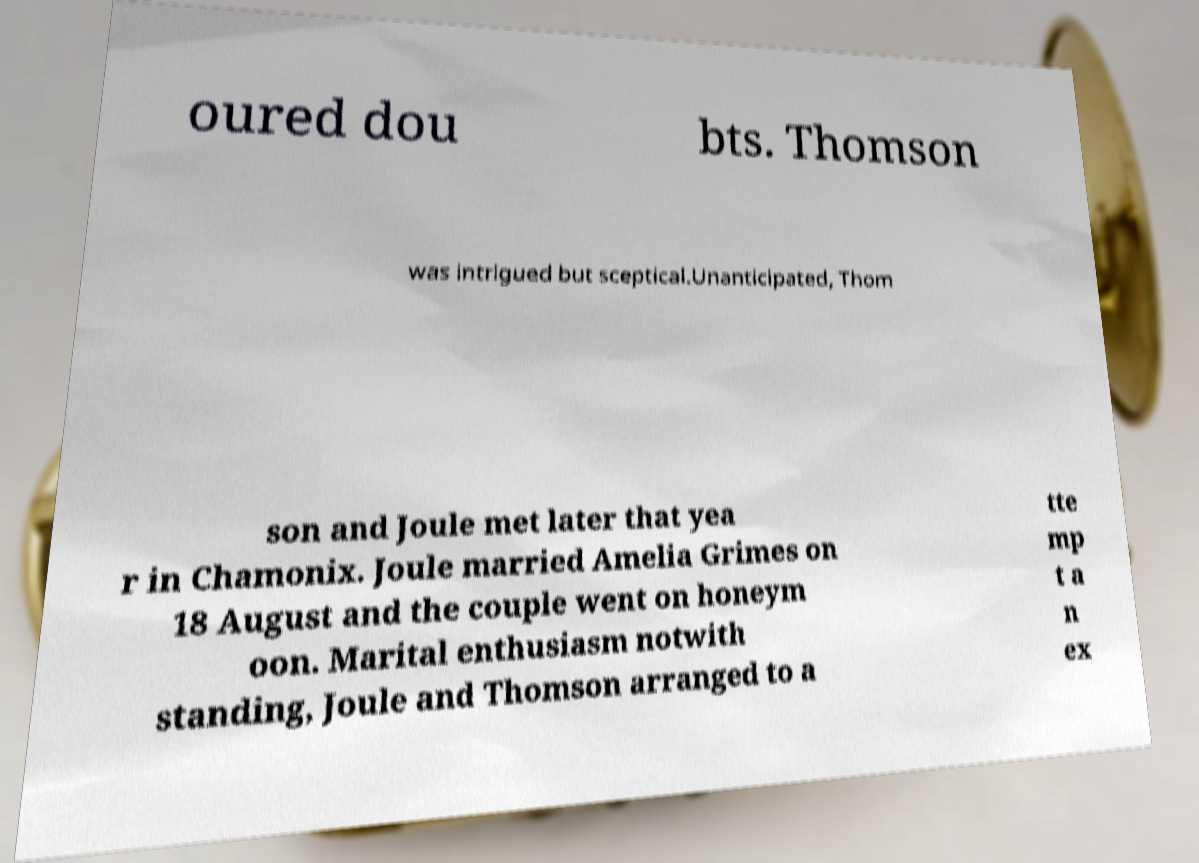There's text embedded in this image that I need extracted. Can you transcribe it verbatim? oured dou bts. Thomson was intrigued but sceptical.Unanticipated, Thom son and Joule met later that yea r in Chamonix. Joule married Amelia Grimes on 18 August and the couple went on honeym oon. Marital enthusiasm notwith standing, Joule and Thomson arranged to a tte mp t a n ex 